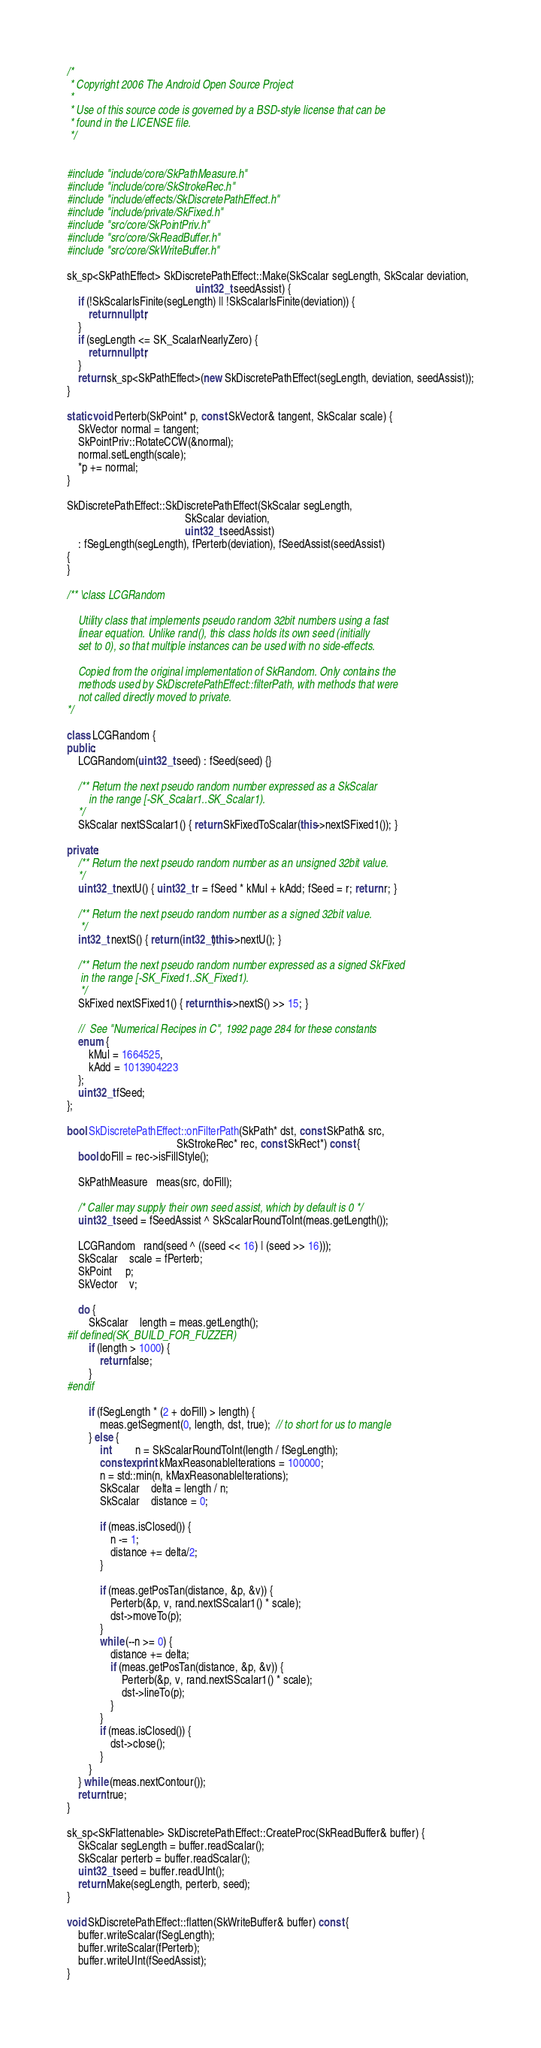<code> <loc_0><loc_0><loc_500><loc_500><_C++_>/*
 * Copyright 2006 The Android Open Source Project
 *
 * Use of this source code is governed by a BSD-style license that can be
 * found in the LICENSE file.
 */


#include "include/core/SkPathMeasure.h"
#include "include/core/SkStrokeRec.h"
#include "include/effects/SkDiscretePathEffect.h"
#include "include/private/SkFixed.h"
#include "src/core/SkPointPriv.h"
#include "src/core/SkReadBuffer.h"
#include "src/core/SkWriteBuffer.h"

sk_sp<SkPathEffect> SkDiscretePathEffect::Make(SkScalar segLength, SkScalar deviation,
                                               uint32_t seedAssist) {
    if (!SkScalarIsFinite(segLength) || !SkScalarIsFinite(deviation)) {
        return nullptr;
    }
    if (segLength <= SK_ScalarNearlyZero) {
        return nullptr;
    }
    return sk_sp<SkPathEffect>(new SkDiscretePathEffect(segLength, deviation, seedAssist));
}

static void Perterb(SkPoint* p, const SkVector& tangent, SkScalar scale) {
    SkVector normal = tangent;
    SkPointPriv::RotateCCW(&normal);
    normal.setLength(scale);
    *p += normal;
}

SkDiscretePathEffect::SkDiscretePathEffect(SkScalar segLength,
                                           SkScalar deviation,
                                           uint32_t seedAssist)
    : fSegLength(segLength), fPerterb(deviation), fSeedAssist(seedAssist)
{
}

/** \class LCGRandom

    Utility class that implements pseudo random 32bit numbers using a fast
    linear equation. Unlike rand(), this class holds its own seed (initially
    set to 0), so that multiple instances can be used with no side-effects.

    Copied from the original implementation of SkRandom. Only contains the
    methods used by SkDiscretePathEffect::filterPath, with methods that were
    not called directly moved to private.
*/

class LCGRandom {
public:
    LCGRandom(uint32_t seed) : fSeed(seed) {}

    /** Return the next pseudo random number expressed as a SkScalar
        in the range [-SK_Scalar1..SK_Scalar1).
    */
    SkScalar nextSScalar1() { return SkFixedToScalar(this->nextSFixed1()); }

private:
    /** Return the next pseudo random number as an unsigned 32bit value.
    */
    uint32_t nextU() { uint32_t r = fSeed * kMul + kAdd; fSeed = r; return r; }

    /** Return the next pseudo random number as a signed 32bit value.
     */
    int32_t nextS() { return (int32_t)this->nextU(); }

    /** Return the next pseudo random number expressed as a signed SkFixed
     in the range [-SK_Fixed1..SK_Fixed1).
     */
    SkFixed nextSFixed1() { return this->nextS() >> 15; }

    //  See "Numerical Recipes in C", 1992 page 284 for these constants
    enum {
        kMul = 1664525,
        kAdd = 1013904223
    };
    uint32_t fSeed;
};

bool SkDiscretePathEffect::onFilterPath(SkPath* dst, const SkPath& src,
                                        SkStrokeRec* rec, const SkRect*) const {
    bool doFill = rec->isFillStyle();

    SkPathMeasure   meas(src, doFill);

    /* Caller may supply their own seed assist, which by default is 0 */
    uint32_t seed = fSeedAssist ^ SkScalarRoundToInt(meas.getLength());

    LCGRandom   rand(seed ^ ((seed << 16) | (seed >> 16)));
    SkScalar    scale = fPerterb;
    SkPoint     p;
    SkVector    v;

    do {
        SkScalar    length = meas.getLength();
#if defined(SK_BUILD_FOR_FUZZER)
        if (length > 1000) {
            return false;
        }
#endif

        if (fSegLength * (2 + doFill) > length) {
            meas.getSegment(0, length, dst, true);  // to short for us to mangle
        } else {
            int         n = SkScalarRoundToInt(length / fSegLength);
            constexpr int kMaxReasonableIterations = 100000;
            n = std::min(n, kMaxReasonableIterations);
            SkScalar    delta = length / n;
            SkScalar    distance = 0;

            if (meas.isClosed()) {
                n -= 1;
                distance += delta/2;
            }

            if (meas.getPosTan(distance, &p, &v)) {
                Perterb(&p, v, rand.nextSScalar1() * scale);
                dst->moveTo(p);
            }
            while (--n >= 0) {
                distance += delta;
                if (meas.getPosTan(distance, &p, &v)) {
                    Perterb(&p, v, rand.nextSScalar1() * scale);
                    dst->lineTo(p);
                }
            }
            if (meas.isClosed()) {
                dst->close();
            }
        }
    } while (meas.nextContour());
    return true;
}

sk_sp<SkFlattenable> SkDiscretePathEffect::CreateProc(SkReadBuffer& buffer) {
    SkScalar segLength = buffer.readScalar();
    SkScalar perterb = buffer.readScalar();
    uint32_t seed = buffer.readUInt();
    return Make(segLength, perterb, seed);
}

void SkDiscretePathEffect::flatten(SkWriteBuffer& buffer) const {
    buffer.writeScalar(fSegLength);
    buffer.writeScalar(fPerterb);
    buffer.writeUInt(fSeedAssist);
}
</code> 